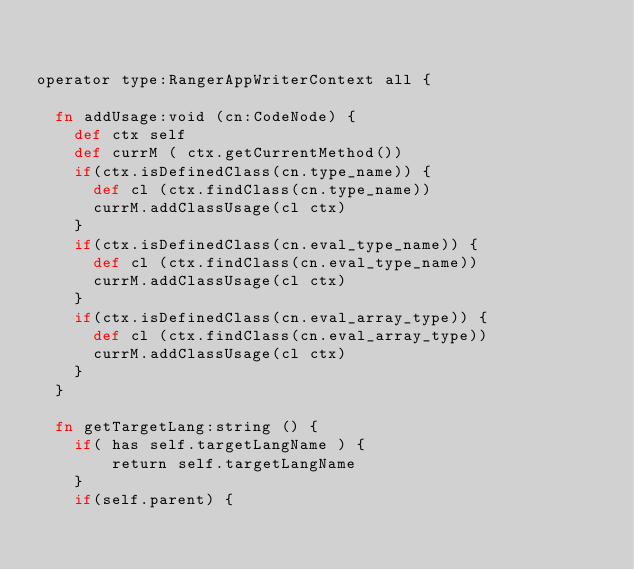<code> <loc_0><loc_0><loc_500><loc_500><_Clojure_>

operator type:RangerAppWriterContext all {

  fn addUsage:void (cn:CodeNode) {
    def ctx self
    def currM ( ctx.getCurrentMethod())
    if(ctx.isDefinedClass(cn.type_name)) {
      def cl (ctx.findClass(cn.type_name))
      currM.addClassUsage(cl ctx)
    }
    if(ctx.isDefinedClass(cn.eval_type_name)) {
      def cl (ctx.findClass(cn.eval_type_name))
      currM.addClassUsage(cl ctx)
    }
    if(ctx.isDefinedClass(cn.eval_array_type)) {
      def cl (ctx.findClass(cn.eval_array_type))
      currM.addClassUsage(cl ctx)
    }
  }

  fn getTargetLang:string () {
    if( has self.targetLangName ) {
        return self.targetLangName
    }
    if(self.parent) {</code> 